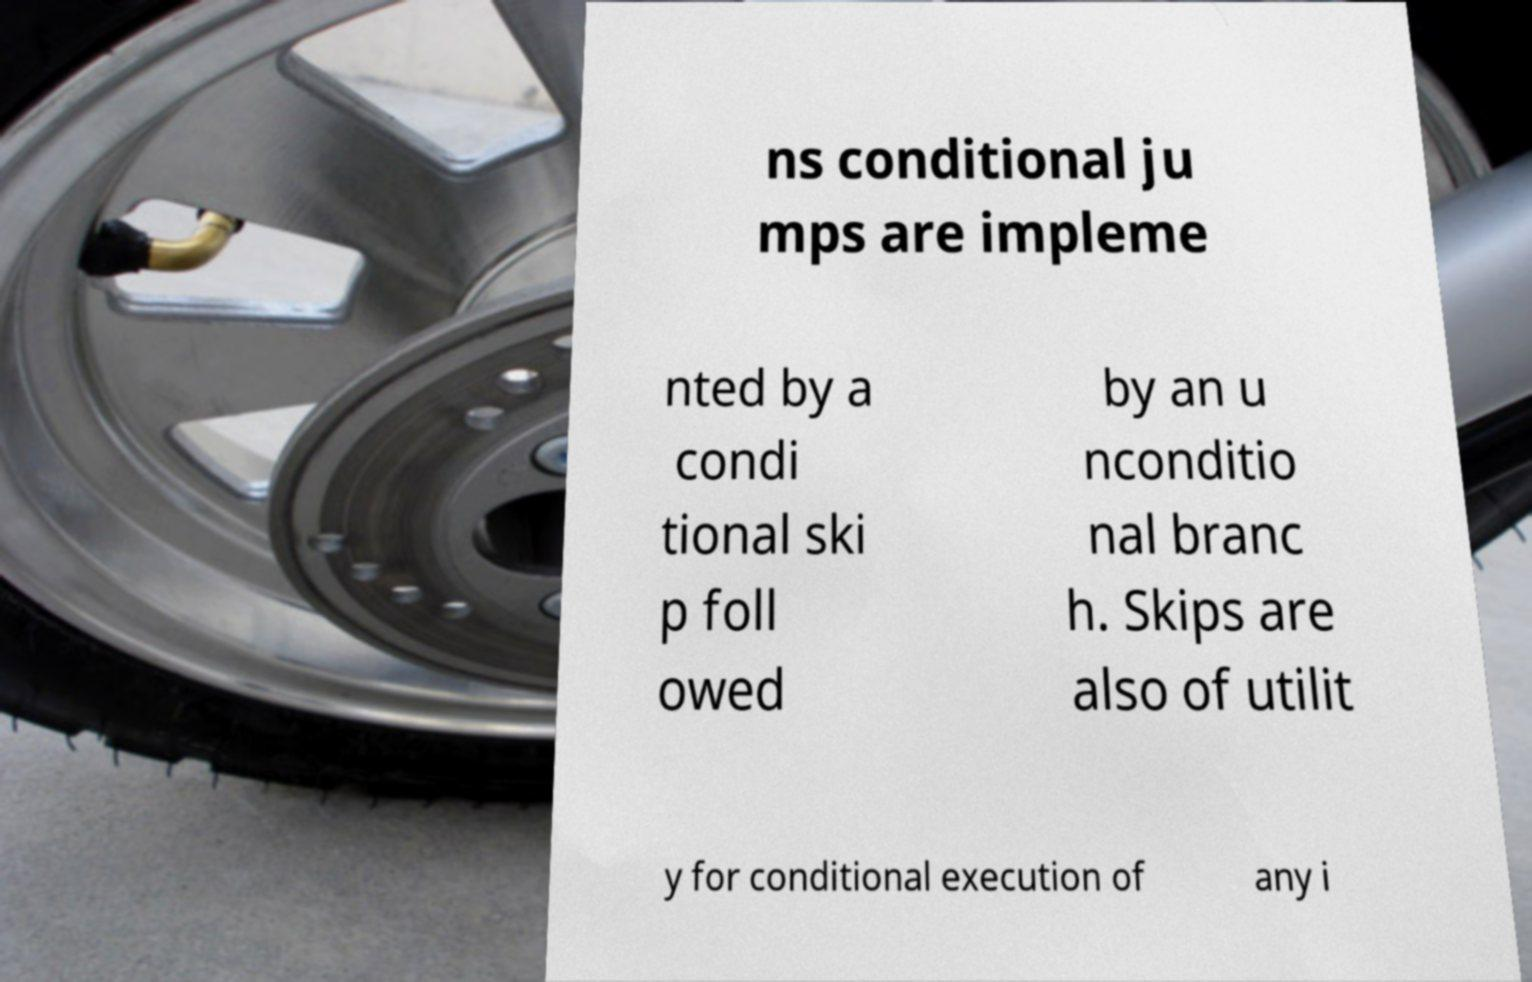For documentation purposes, I need the text within this image transcribed. Could you provide that? ns conditional ju mps are impleme nted by a condi tional ski p foll owed by an u nconditio nal branc h. Skips are also of utilit y for conditional execution of any i 